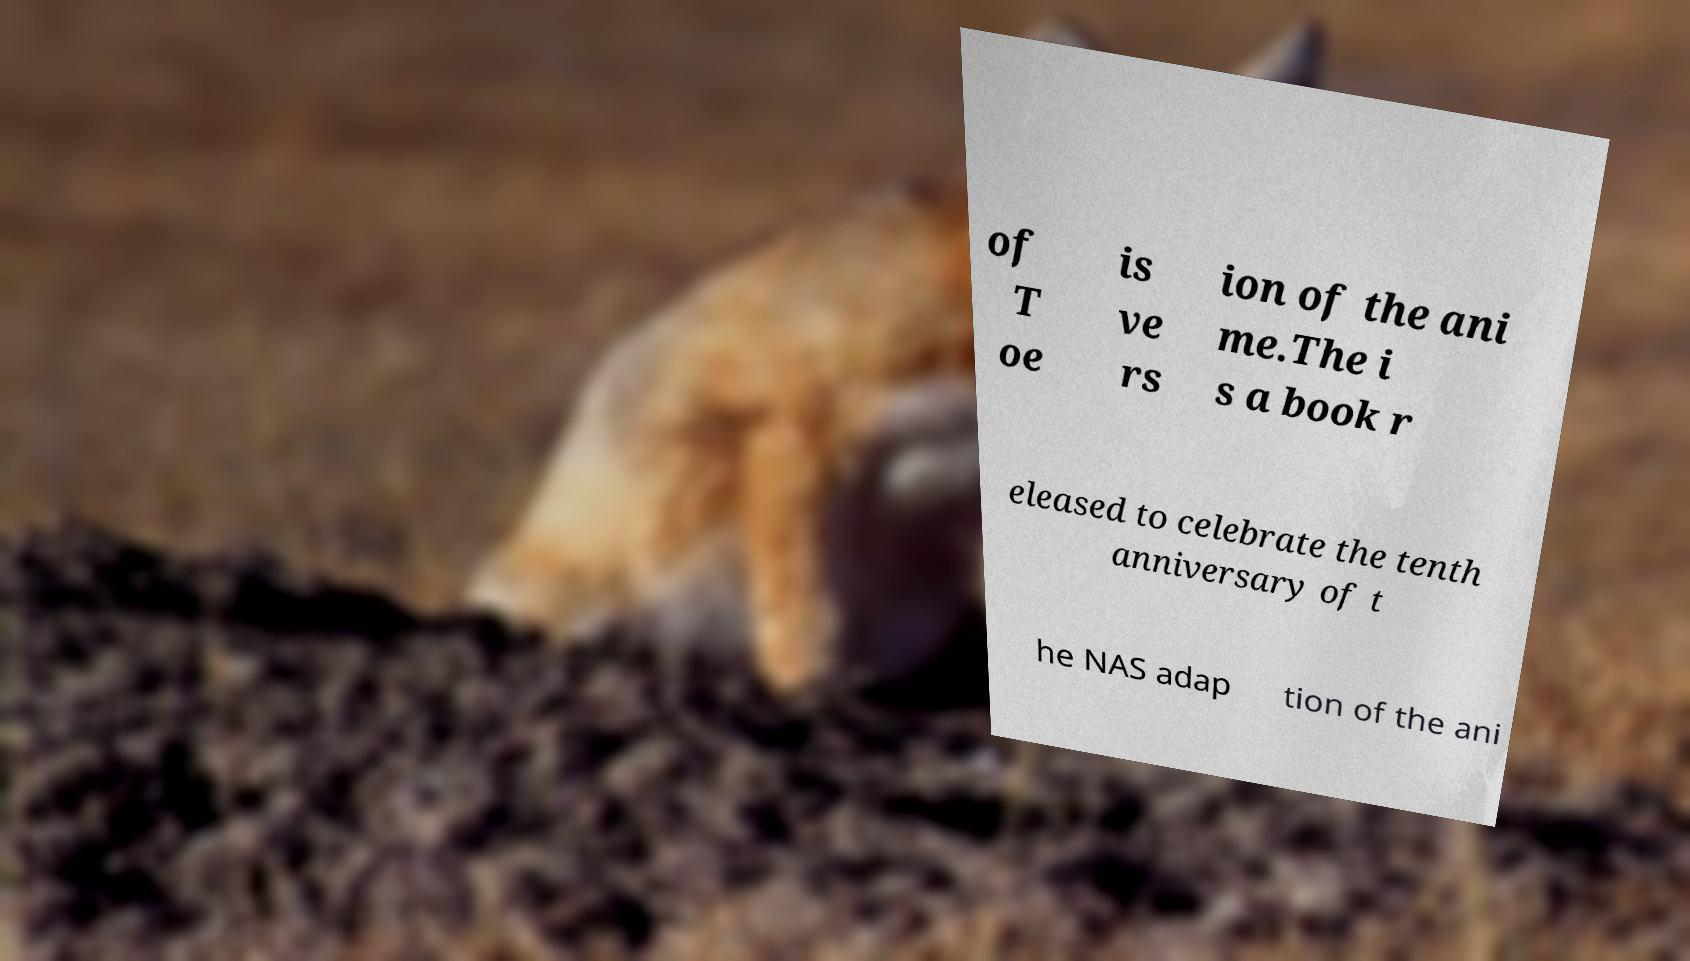I need the written content from this picture converted into text. Can you do that? of T oe is ve rs ion of the ani me.The i s a book r eleased to celebrate the tenth anniversary of t he NAS adap tion of the ani 